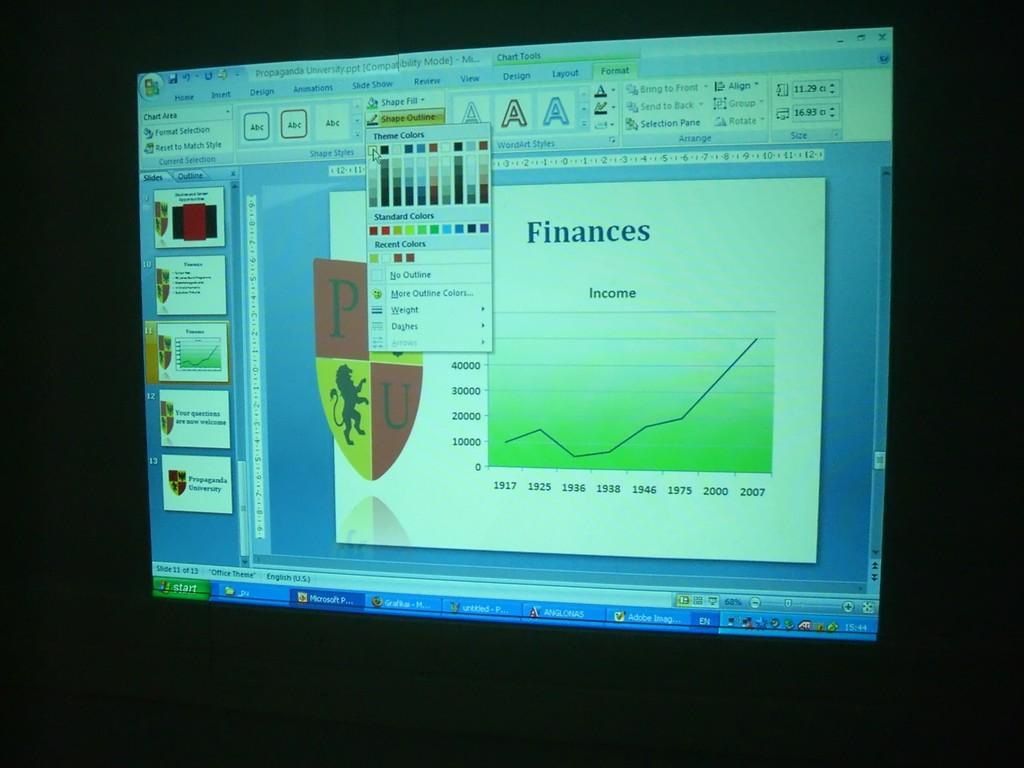<image>
Give a short and clear explanation of the subsequent image. A computer screen shows a slideshow for Finances being created 